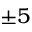Convert formula to latex. <formula><loc_0><loc_0><loc_500><loc_500>\pm 5</formula> 